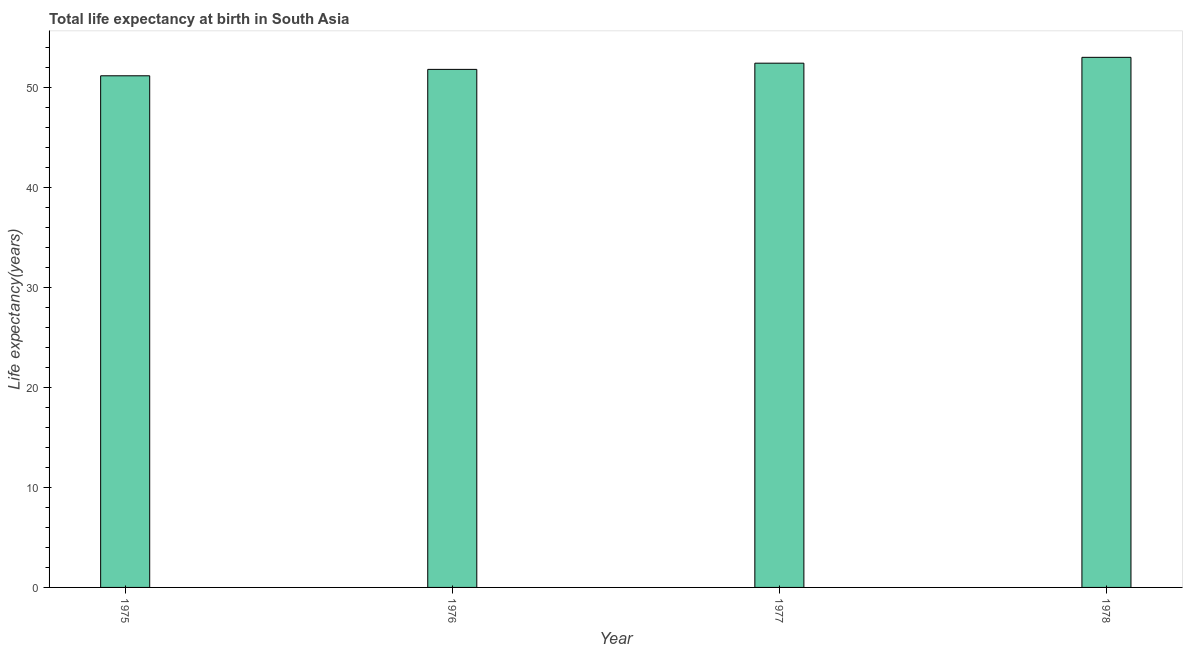Does the graph contain any zero values?
Offer a very short reply. No. What is the title of the graph?
Offer a terse response. Total life expectancy at birth in South Asia. What is the label or title of the X-axis?
Offer a very short reply. Year. What is the label or title of the Y-axis?
Ensure brevity in your answer.  Life expectancy(years). What is the life expectancy at birth in 1978?
Give a very brief answer. 53. Across all years, what is the maximum life expectancy at birth?
Your answer should be compact. 53. Across all years, what is the minimum life expectancy at birth?
Offer a terse response. 51.16. In which year was the life expectancy at birth maximum?
Offer a very short reply. 1978. In which year was the life expectancy at birth minimum?
Your answer should be compact. 1975. What is the sum of the life expectancy at birth?
Provide a succinct answer. 208.38. What is the difference between the life expectancy at birth in 1975 and 1977?
Give a very brief answer. -1.26. What is the average life expectancy at birth per year?
Give a very brief answer. 52.09. What is the median life expectancy at birth?
Offer a terse response. 52.11. What is the ratio of the life expectancy at birth in 1975 to that in 1977?
Give a very brief answer. 0.98. Is the difference between the life expectancy at birth in 1976 and 1978 greater than the difference between any two years?
Your response must be concise. No. What is the difference between the highest and the second highest life expectancy at birth?
Offer a very short reply. 0.58. What is the difference between the highest and the lowest life expectancy at birth?
Ensure brevity in your answer.  1.85. How many bars are there?
Provide a short and direct response. 4. Are all the bars in the graph horizontal?
Offer a terse response. No. What is the Life expectancy(years) in 1975?
Your answer should be very brief. 51.16. What is the Life expectancy(years) of 1976?
Offer a very short reply. 51.8. What is the Life expectancy(years) of 1977?
Offer a terse response. 52.42. What is the Life expectancy(years) in 1978?
Make the answer very short. 53. What is the difference between the Life expectancy(years) in 1975 and 1976?
Provide a short and direct response. -0.64. What is the difference between the Life expectancy(years) in 1975 and 1977?
Your response must be concise. -1.26. What is the difference between the Life expectancy(years) in 1975 and 1978?
Your answer should be compact. -1.85. What is the difference between the Life expectancy(years) in 1976 and 1977?
Your answer should be compact. -0.62. What is the difference between the Life expectancy(years) in 1976 and 1978?
Provide a short and direct response. -1.21. What is the difference between the Life expectancy(years) in 1977 and 1978?
Offer a very short reply. -0.59. What is the ratio of the Life expectancy(years) in 1976 to that in 1977?
Provide a short and direct response. 0.99. 